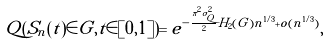<formula> <loc_0><loc_0><loc_500><loc_500>Q ( S _ { n } ( t ) \in G , t \in [ 0 , 1 ] ) = e ^ { - \frac { \pi ^ { 2 } \sigma _ { Q } ^ { 2 } } { 2 } H _ { 2 } ( G ) n ^ { 1 / 3 } + o ( n ^ { 1 / 3 } ) } ,</formula> 